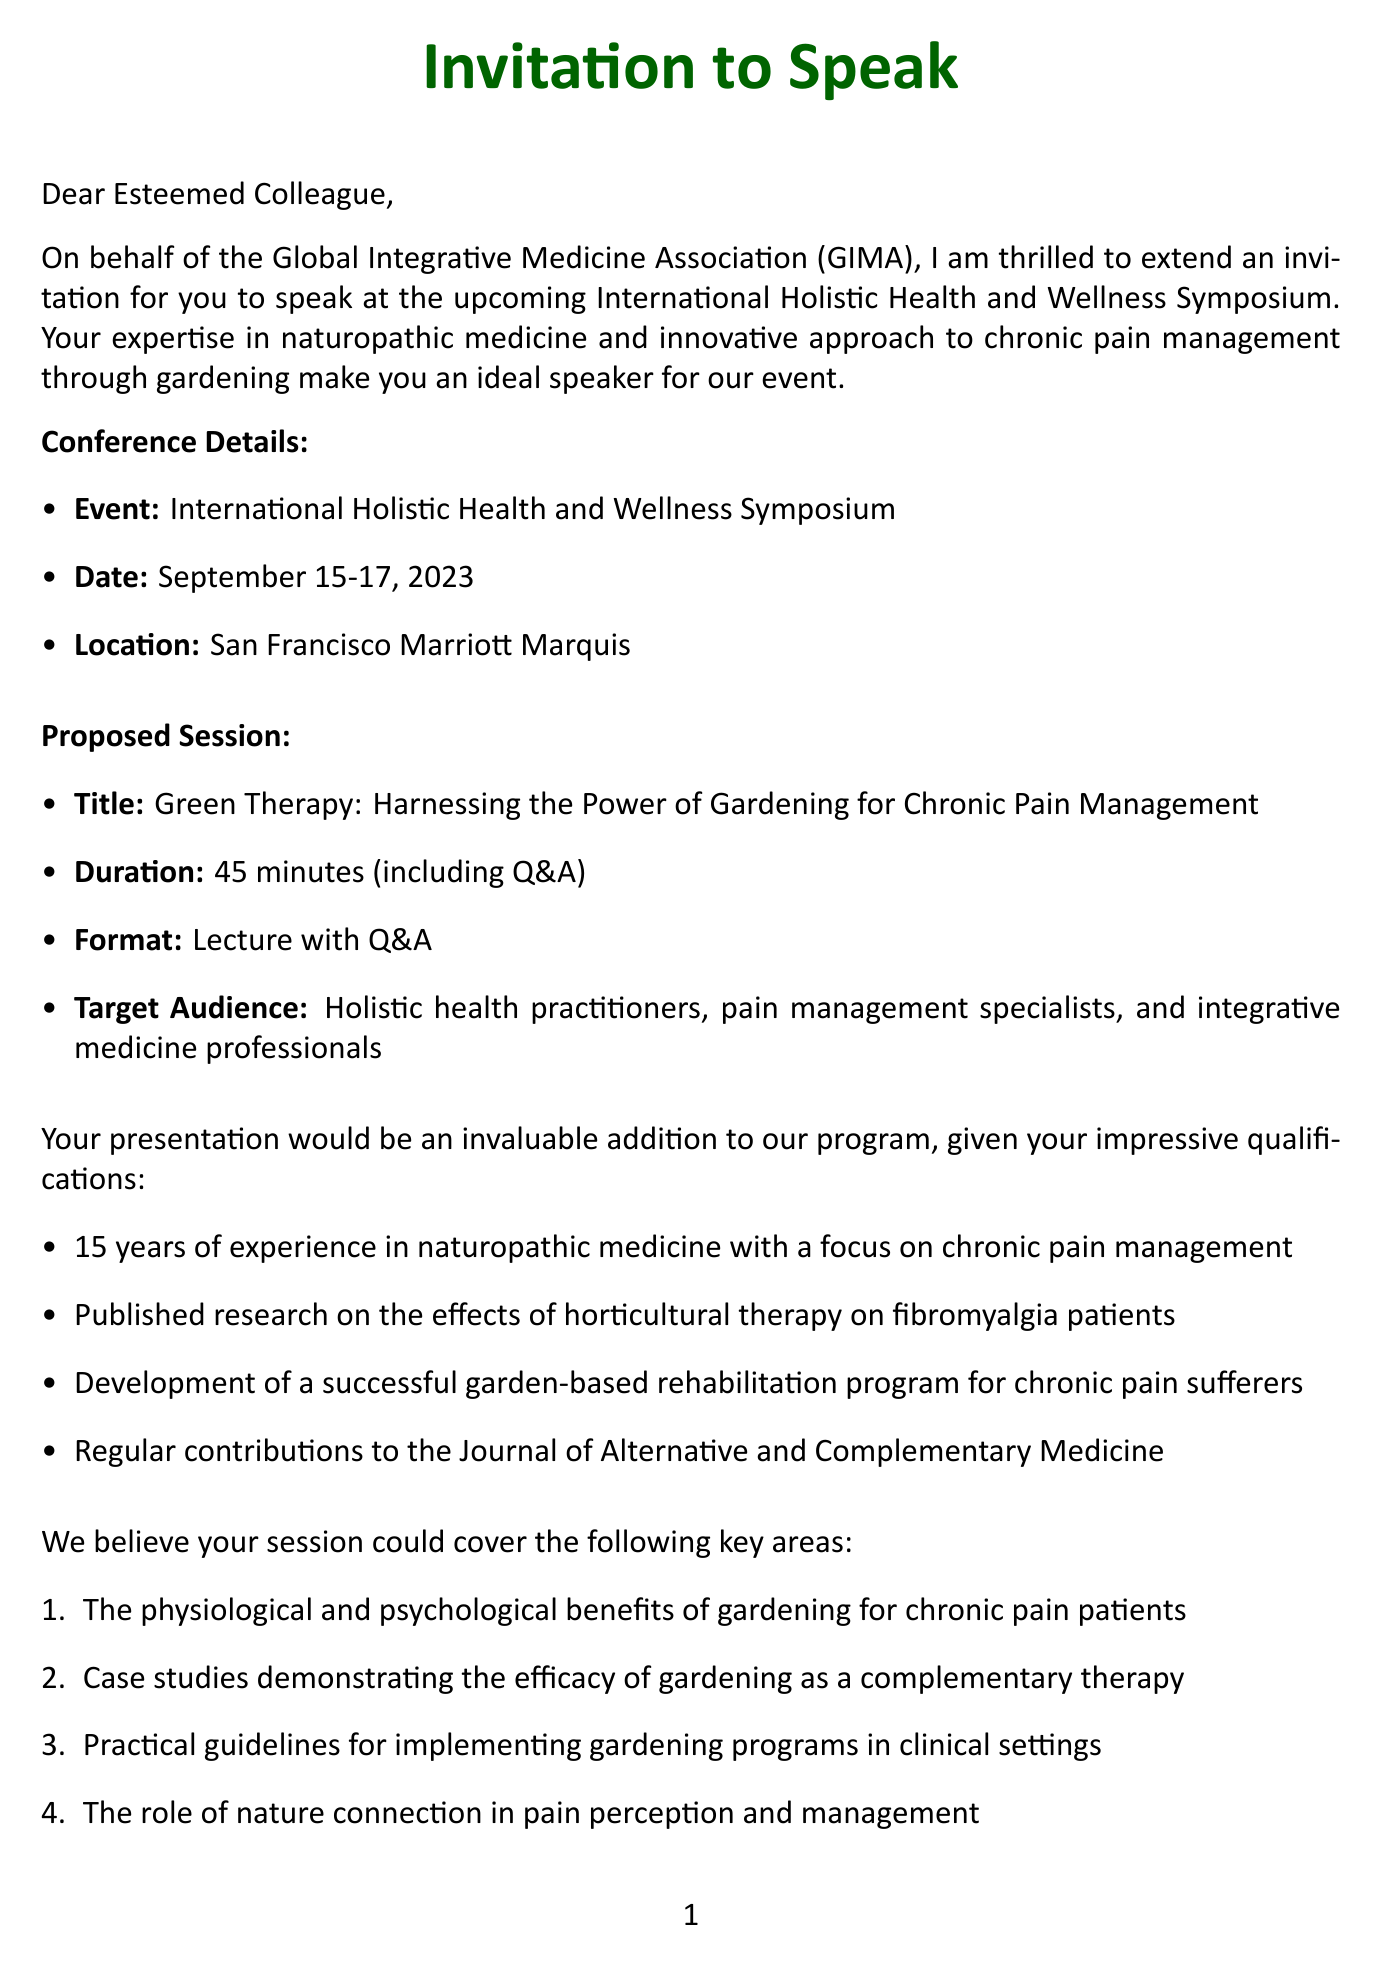what is the name of the conference? The name of the conference is provided in the conference details section of the document.
Answer: International Holistic Health and Wellness Symposium what are the dates of the conference? The dates of the conference are explicitly stated in the conference details section.
Answer: September 15-17, 2023 who is organizing the event? The organizer's name is mentioned in the conference details section.
Answer: Global Integrative Medicine Association (GIMA) what is the session title proposed for the speaker? The session title is listed under the proposed session in the document.
Answer: Green Therapy: Harnessing the Power of Gardening for Chronic Pain Management how long is the proposed session duration? The session duration is specified in the proposed session details of the document.
Answer: 45 minutes what is one of the notable achievements of the speaker? The notable achievements of the speaker are listed in their qualifications section.
Answer: Published research on the effects of horticultural therapy on fibromyalgia patients what is one topic that should be covered in the presentation? The document lists various topics that could be included in the presentation.
Answer: The physiological and psychological benefits of gardening for chronic pain patients how many years of experience does the speaker have? The years of experience are mentioned in the speaker qualifications section.
Answer: 15 years what is a practical recommendation mentioned in the document? The document includes several practical recommendations for gardening programs.
Answer: Adapting gardening tools and techniques for patients with limited mobility what is a relevant organization mentioned in the document? Relevant organizations are listed towards the end of the letter.
Answer: American Horticultural Therapy Association 